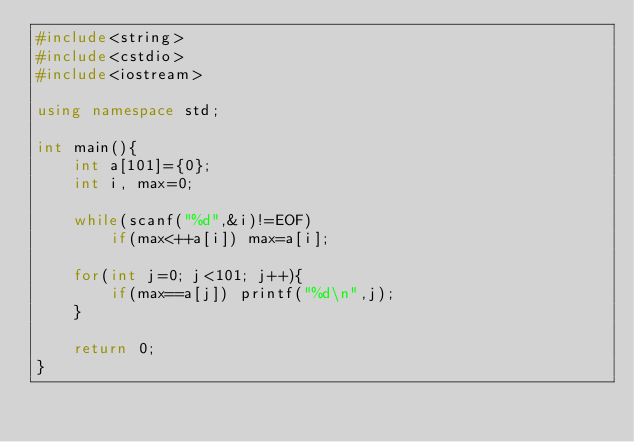Convert code to text. <code><loc_0><loc_0><loc_500><loc_500><_C++_>#include<string>
#include<cstdio>
#include<iostream>

using namespace std;
 
int main(){
	int a[101]={0};
	int i, max=0;

	while(scanf("%d",&i)!=EOF)
		if(max<++a[i]) max=a[i];

	for(int j=0; j<101; j++){
		if(max==a[j]) printf("%d\n",j);
	}

    return 0;
}</code> 